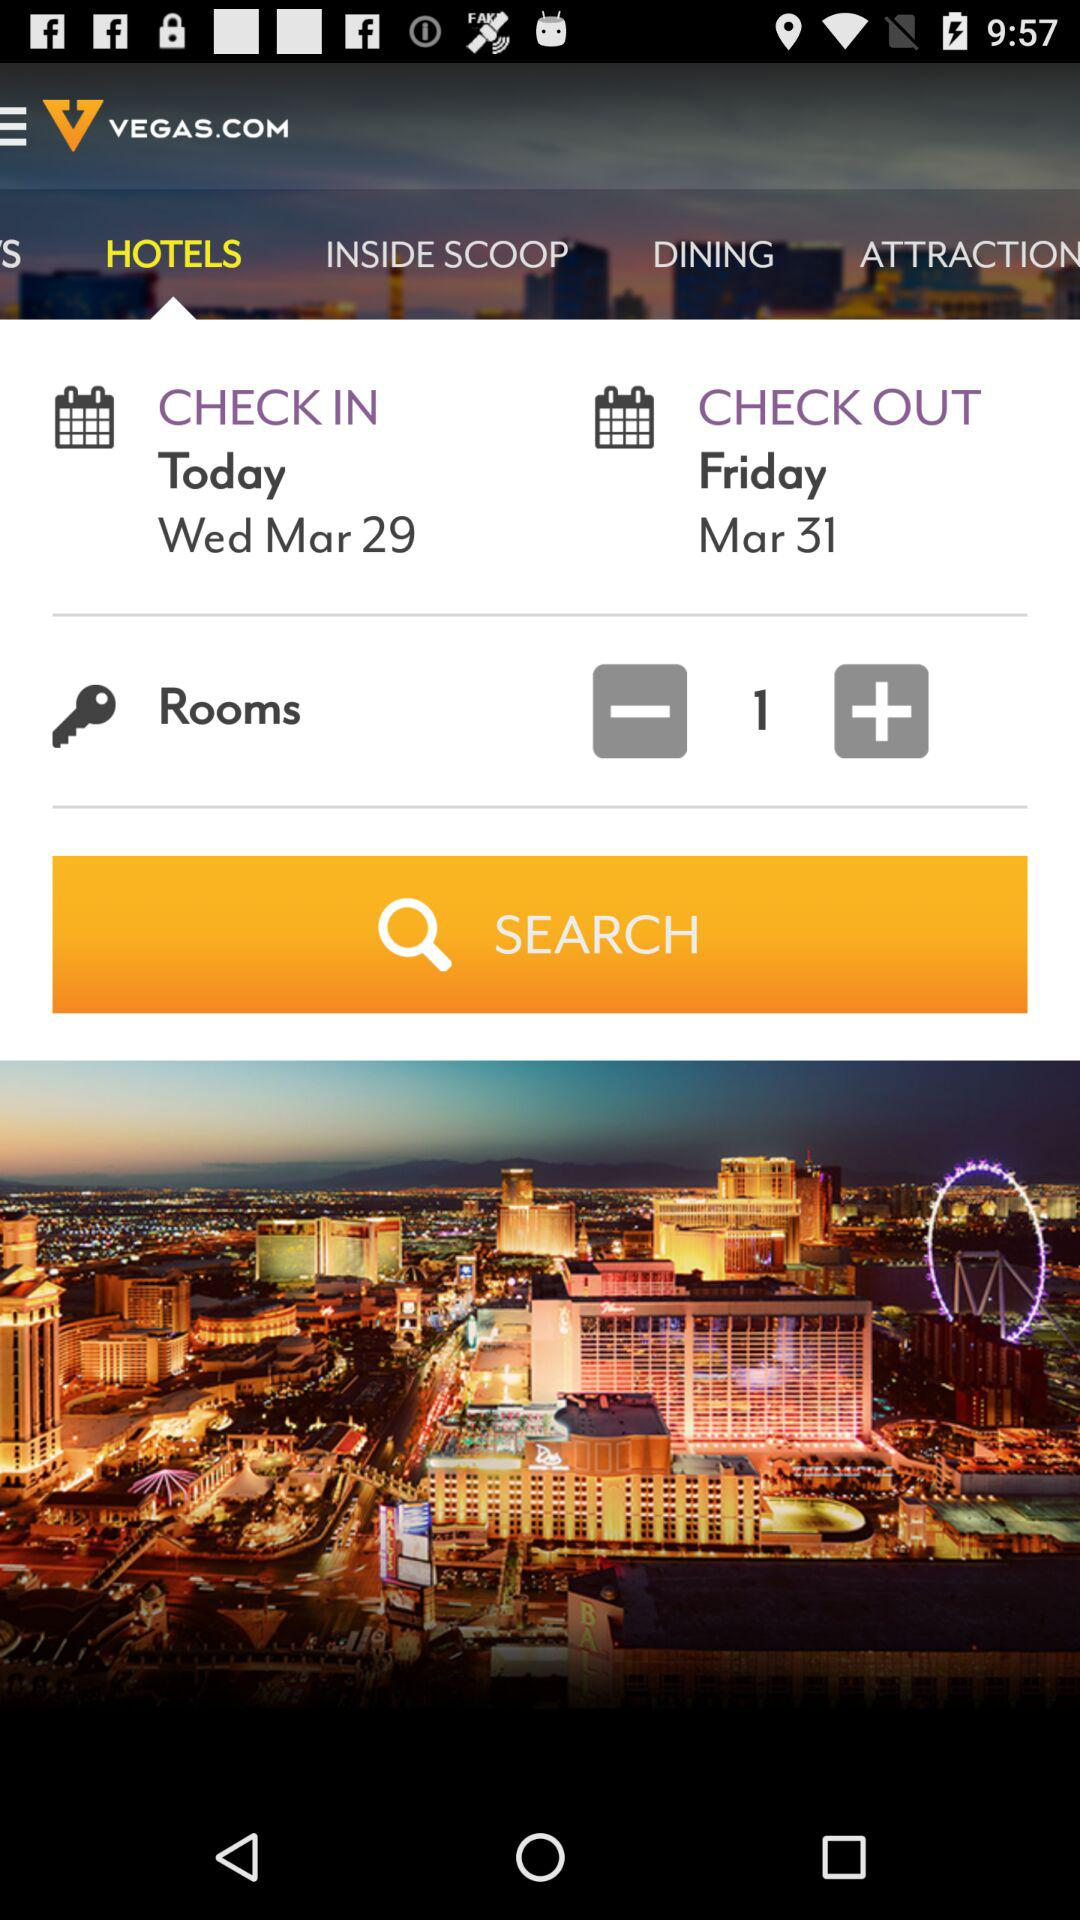What day is the check-in at the hotel? The day is Wednesday. 